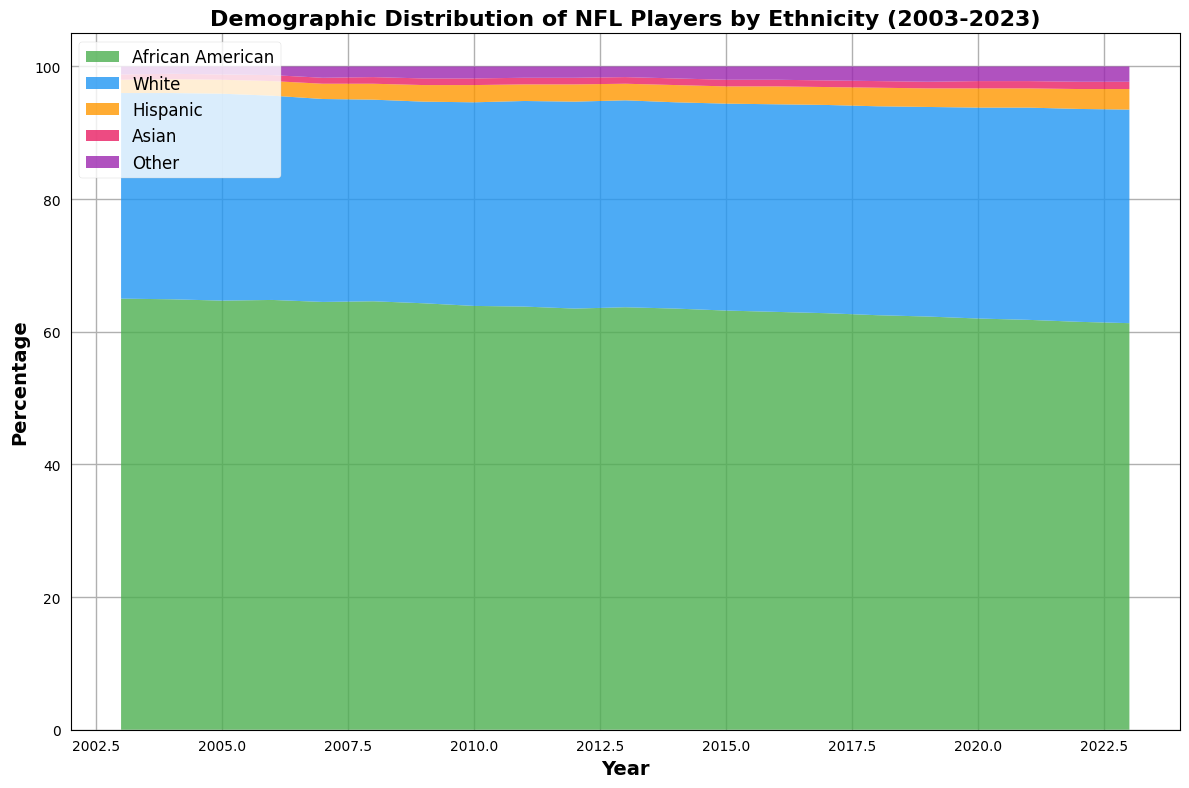What is the overall trend for African American players from 2003 to 2023? By looking at the area for African American players, we can observe a steady decrease. It starts around 65.0% in 2003 and ends at 61.3% in 2023, indicating a gradual decline over the 20 years.
Answer: Declining Which ethnicity had the largest increase in percentage over the last 20 years? By comparing the percentages in 2003 and 2023, Hispanic players increased from 2.0% to 3.1%, and White players also showed an increase from 31.0% to 32.2%. Hispanic players showed the largest increase by visual comparison.
Answer: Hispanic What is the combined percentage of Hispanic and Asian players in 2023? In 2023, Hispanic players are 3.1% and Asian players are 1.1%. Adding these values gives 3.1% + 1.1% = 4.2%.
Answer: 4.2% In which year did White players have the highest percentage? The highest percentage for White players is at 32.2% in 2023 by visually scanning the white area trend over the years.
Answer: 2023 Which two ethnic groups had the closest percentages in any given year, and what were the values? In multiple years, "Asian" and "Other" categories are very close. For instance, in 2007, Asian players had 0.9% and Other had 1.7%, a difference of 0.8%. Scanning through the data, the closest is in 2011 with both having around 1.0% and 1.7%, a difference of 0.7%.
Answer: Asian: 1.0%, Other: 1.7% (2011) At what year does the percentage of African American players drop below 63%? By scanning the trend, the percentage of African American players first drops below 63% in 2017 at 62.8%.
Answer: 2017 What can be said about the variability of the demographic composition in the last 20 years? Over 20 years, African American and White categories have shown noticeable changes, with a gradual decline in African American and slight rise in White percentages. Other categories like Hispanic, Asian, and Others show less variability but a general incremental change.
Answer: Gradual changes, mostly stable with slight increases What is the net change in the percentage of ‘Other’ players from 2003 to 2023? In 2003, Other players were at 1.2% and increased to 2.3% by 2023. The net change is 2.3% - 1.2% = 1.1%.
Answer: 1.1% Which year saw a peak in the percentage of Hispanic players, and what was its value? In visually analyzing the Hispanic area, 2023 saw the peak in Hispanic players at 3.1%.
Answer: 2023, 3.1% 